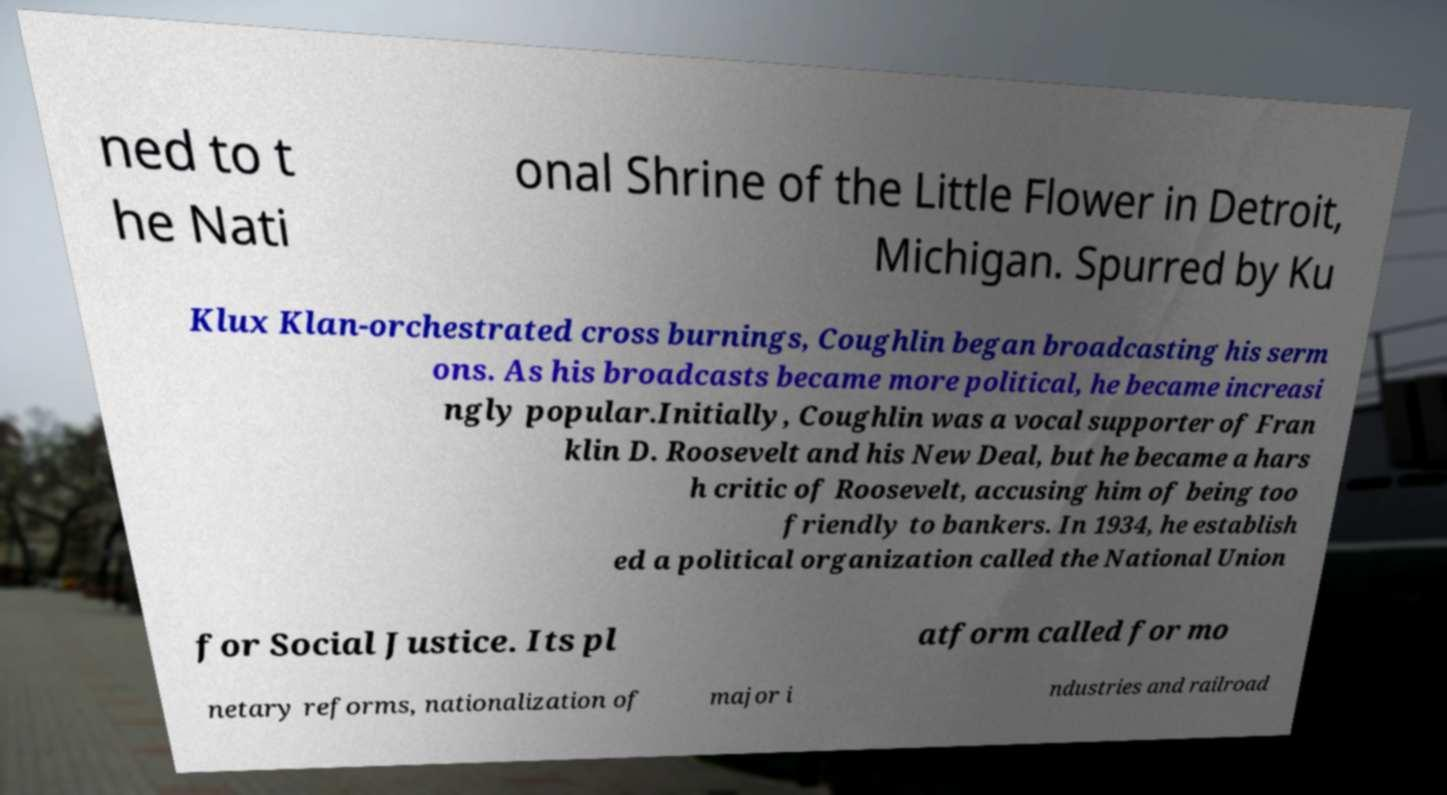For documentation purposes, I need the text within this image transcribed. Could you provide that? ned to t he Nati onal Shrine of the Little Flower in Detroit, Michigan. Spurred by Ku Klux Klan-orchestrated cross burnings, Coughlin began broadcasting his serm ons. As his broadcasts became more political, he became increasi ngly popular.Initially, Coughlin was a vocal supporter of Fran klin D. Roosevelt and his New Deal, but he became a hars h critic of Roosevelt, accusing him of being too friendly to bankers. In 1934, he establish ed a political organization called the National Union for Social Justice. Its pl atform called for mo netary reforms, nationalization of major i ndustries and railroad 